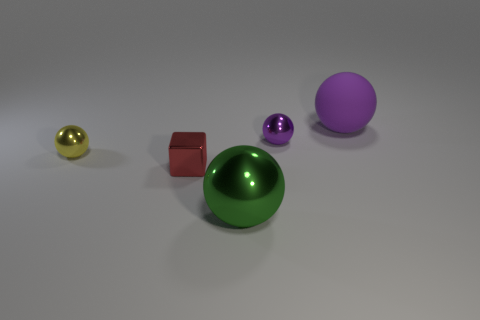Add 5 large shiny things. How many objects exist? 10 Subtract all small yellow balls. How many balls are left? 3 Subtract 1 spheres. How many spheres are left? 3 Subtract all spheres. How many objects are left? 1 Add 2 yellow metallic things. How many yellow metallic things exist? 3 Subtract all green balls. How many balls are left? 3 Subtract 0 blue cubes. How many objects are left? 5 Subtract all red spheres. Subtract all cyan cylinders. How many spheres are left? 4 Subtract all purple cylinders. How many yellow blocks are left? 0 Subtract all large purple objects. Subtract all tiny red shiny objects. How many objects are left? 3 